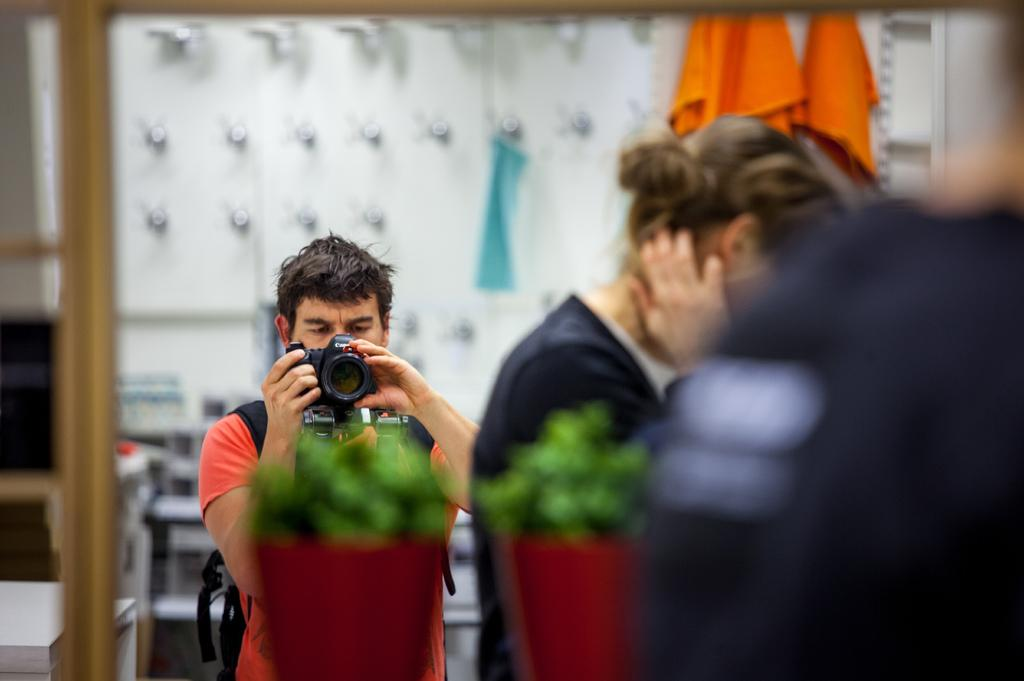Who is the main subject in the image? There is a man in the image. Where is the man located in the image? The man is standing in the middle of the image. What is the man doing in the image? The man is using a camera. Are there any other people in the image besides the man? Yes, there is a woman in the image. Where is the woman located in the image? The woman is on the right side of the image. How many pigs are visible in the image? There are no pigs present in the image. What type of rings is the man wearing on his fingers in the image? There is no mention of rings in the image, and the man's fingers are not visible. 